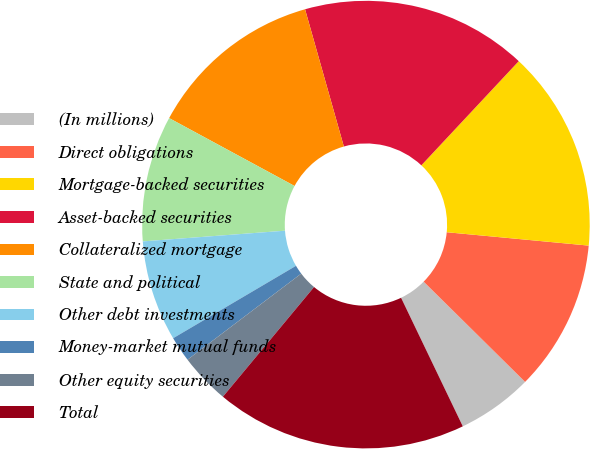<chart> <loc_0><loc_0><loc_500><loc_500><pie_chart><fcel>(In millions)<fcel>Direct obligations<fcel>Mortgage-backed securities<fcel>Asset-backed securities<fcel>Collateralized mortgage<fcel>State and political<fcel>Other debt investments<fcel>Money-market mutual funds<fcel>Other equity securities<fcel>Total<nl><fcel>5.47%<fcel>10.91%<fcel>14.53%<fcel>16.35%<fcel>12.72%<fcel>9.09%<fcel>7.28%<fcel>1.84%<fcel>3.65%<fcel>18.16%<nl></chart> 